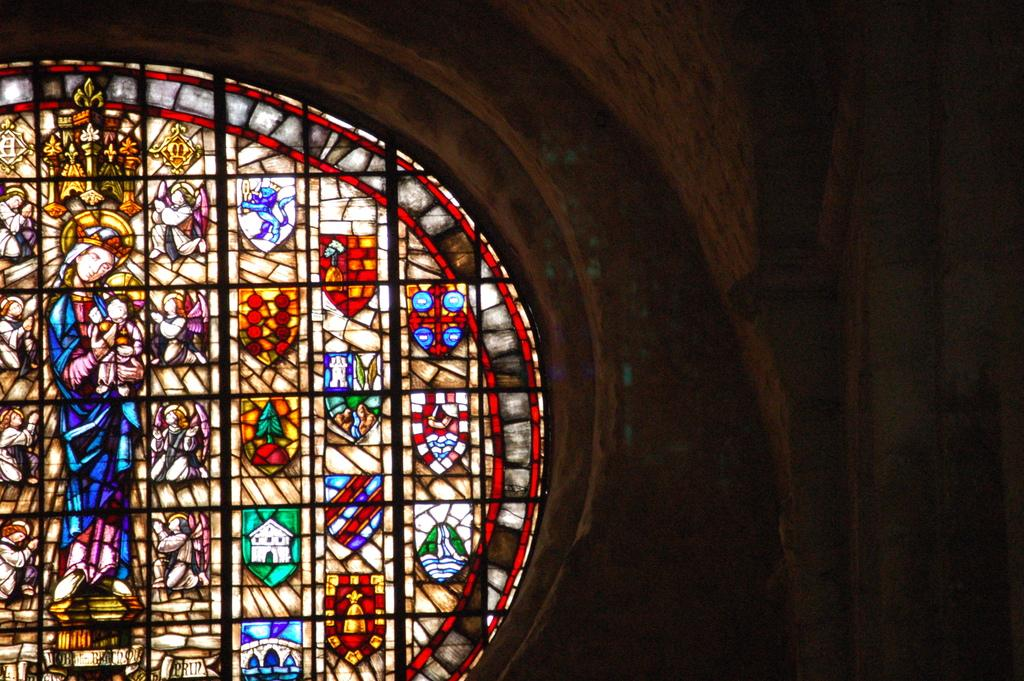What type of building is depicted in the image? The image shows an inside view of a church. Are there any objects visible in the image? Yes, there is a glass in the image. What can be seen on the walls of the church? There is a painting of a woman standing and holding a baby in the image. How many trees are visible inside the church in the image? There are no trees visible inside the church in the image. What is the reaction of the people in the image when they see the surprise? There are no people or surprises mentioned in the image, so we cannot answer this question. 